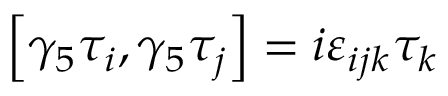<formula> <loc_0><loc_0><loc_500><loc_500>\left [ \gamma _ { 5 } \tau _ { i } , \gamma _ { 5 } \tau _ { j } \right ] = i \varepsilon _ { i j k } \tau _ { k }</formula> 